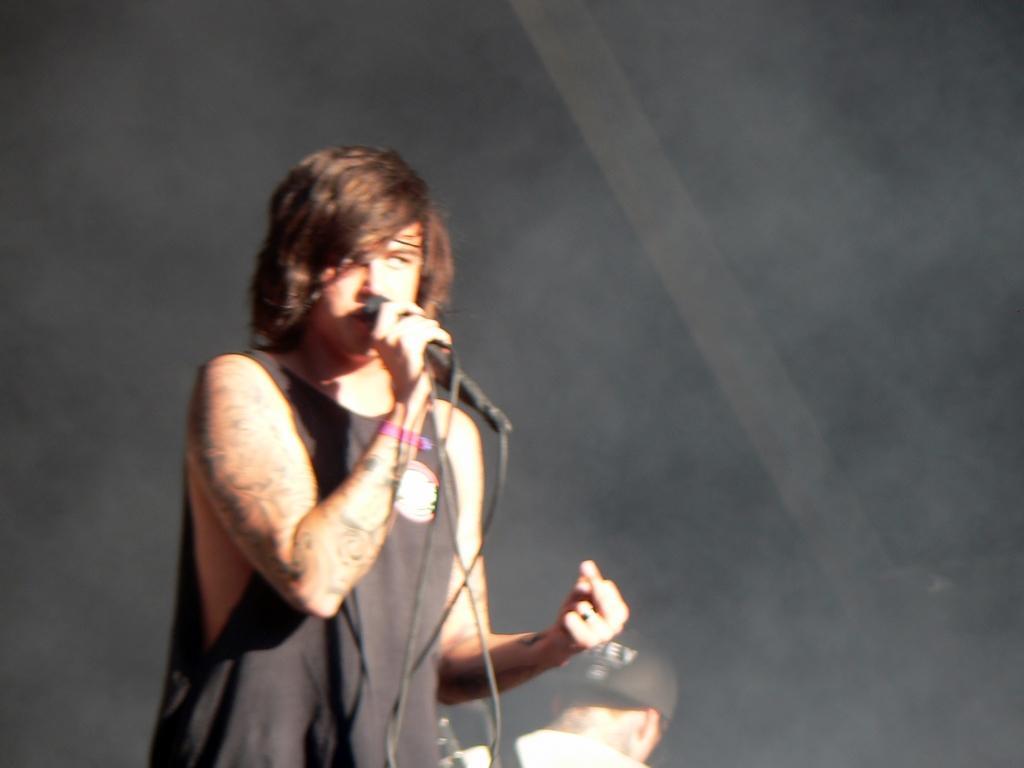Please provide a concise description of this image. In this image there is a man he is wearing black T-shirt holding mic in his hand, beside that man there is another person. 